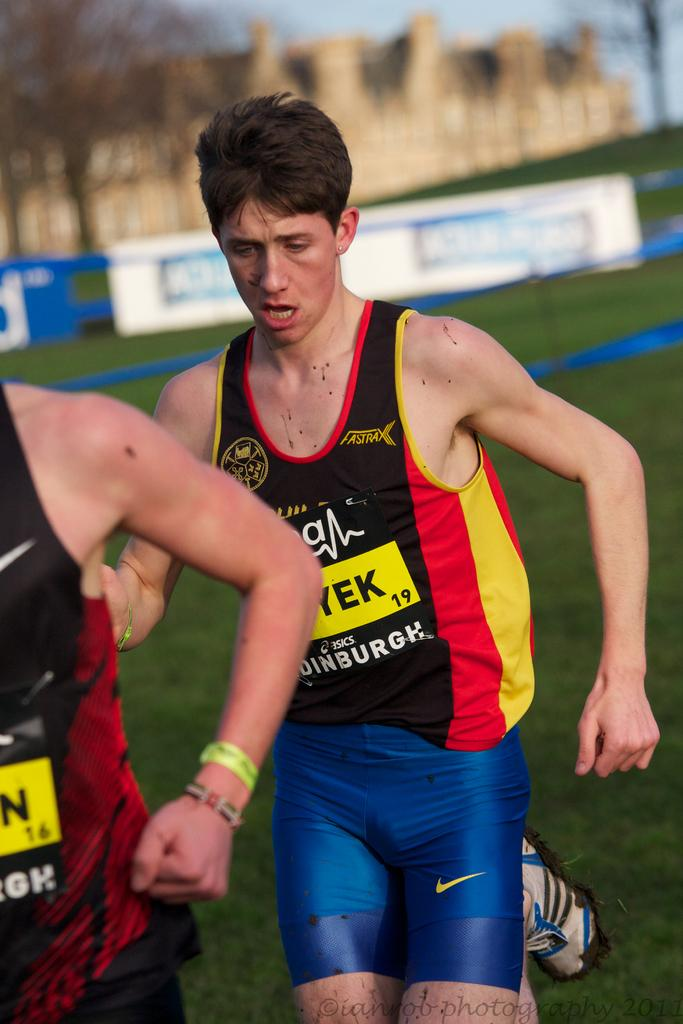<image>
Offer a succinct explanation of the picture presented. A runner has the number 19 on his jersey. 